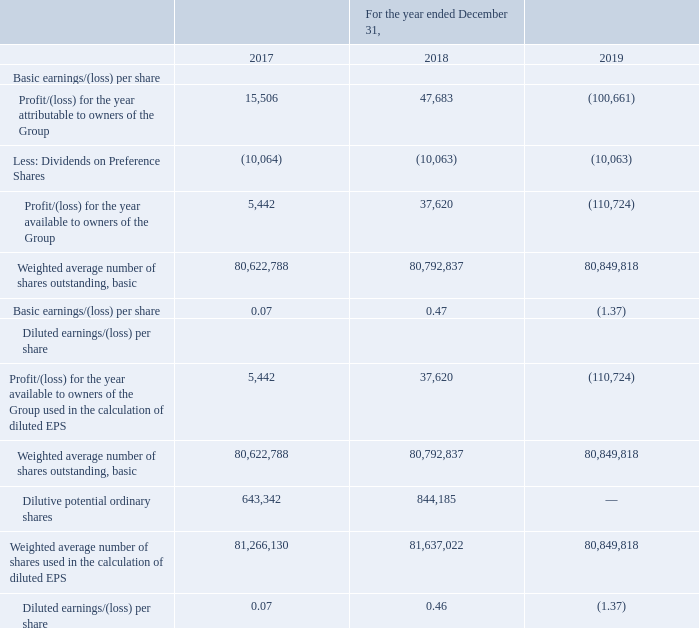GasLog Ltd. and its Subsidiaries
Notes to the consolidated financial statements (Continued)
For the years ended December 31, 2017, 2018 and 2019
(All amounts expressed in thousands of U.S. Dollars, except share and per share data)
29. Earnings/(losses) per share (‘‘EPS’’)
Basic earnings/(losses) per share was calculated by dividing the profit/(loss) for the year attributable to the owners of the common shares after deducting the dividend on Preference Shares by the weighted average number of common shares issued and outstanding during the year.
Diluted EPS is calculated by dividing the profit/(loss) for the year attributable to the owners of the Group adjusted for the effects of all dilutive potential ordinary shares by the weighted average number of all potential ordinary shares assumed to have been converted into common shares, unless such potential ordinary shares have an antidilutive effect.
The following reflects the earnings/(losses) and share data used in the basic and diluted earnings/ (losses) per share computations:
The Group excluded the effect of 2,630,173 SARs and 367,162 RSUs in calculating diluted EPS for the year ended December 31, 2019, as they were anti-dilutive (December 31, 2018: 555,453 SARs and 0 RSUs, December 31, 2017: 998,502 SARs and 0 RSUs).
How was basic earnings/(losses) per share calculated? By dividing the profit/(loss) for the year attributable to the owners of the common shares after deducting the dividend on preference shares by the weighted average number of common shares issued and outstanding during the year. In which years was the earnings/(losses) per share recorded for? 2017, 2018, 2019. How was diluted EPS calculated? Diluted eps is calculated by dividing the profit/(loss) for the year attributable to the owners of the group adjusted for the effects of all dilutive potential ordinary shares by the weighted average number of all potential ordinary shares assumed to have been converted into common shares, unless such potential ordinary shares have an antidilutive effect. Which year was the basic earnings per share the highest? 0.47 > 0.07 > (1.37)
Answer: 2018. What was the change in basic EPS from 2018 to 2019? (1.37) - 0.47 
Answer: -1.84. What was the percentage change in diluted EPS from 2017 to 2018?
Answer scale should be: percent. (0.46 - 0.07)/0.07 
Answer: 557.14. 